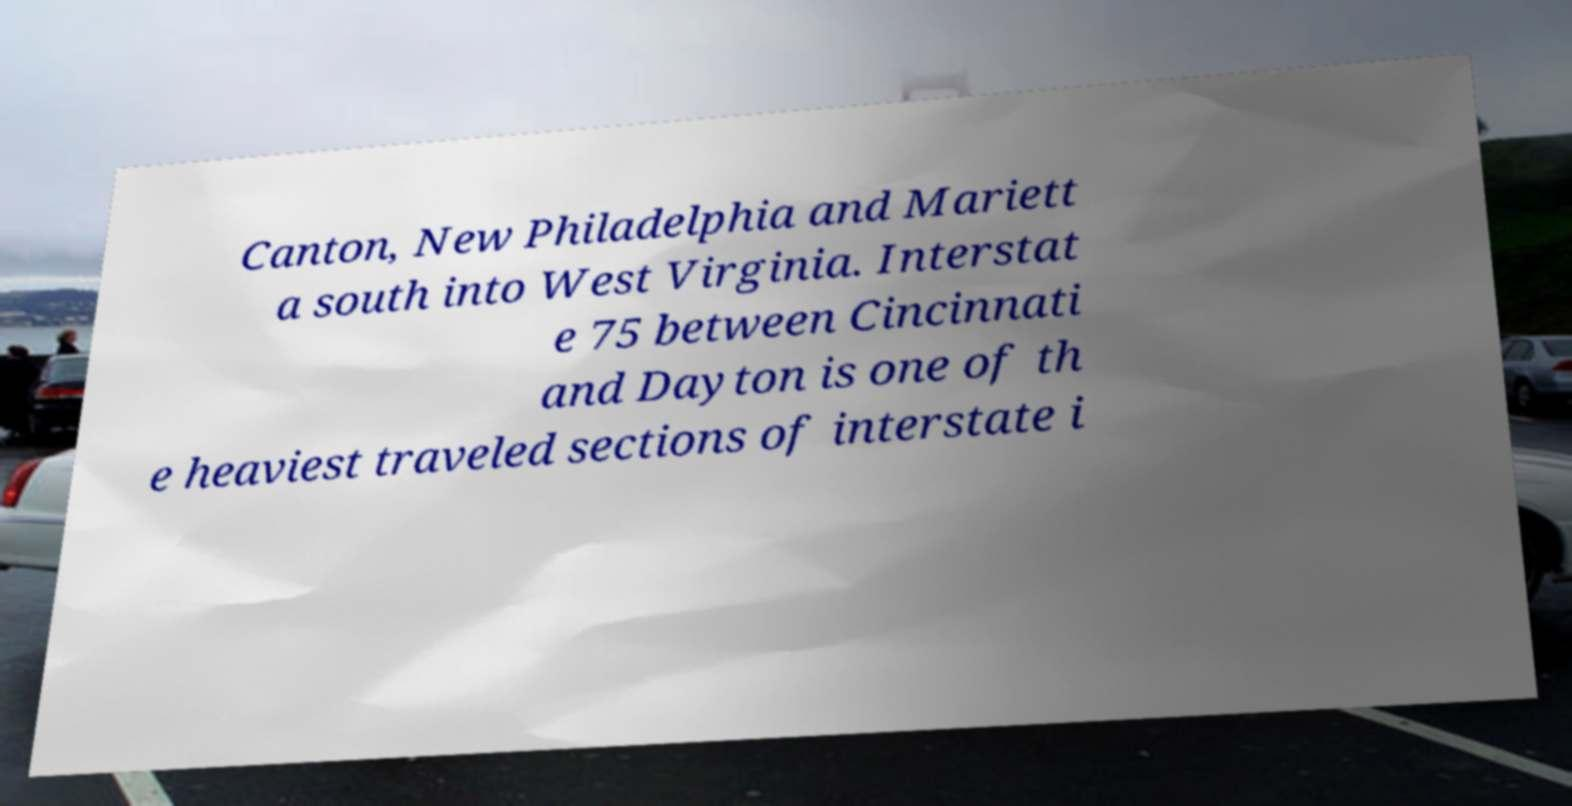Could you extract and type out the text from this image? Canton, New Philadelphia and Mariett a south into West Virginia. Interstat e 75 between Cincinnati and Dayton is one of th e heaviest traveled sections of interstate i 